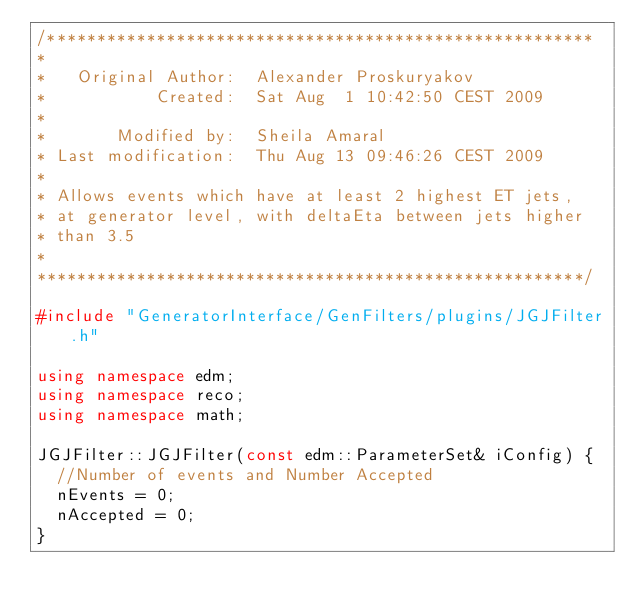Convert code to text. <code><loc_0><loc_0><loc_500><loc_500><_C++_>/*******************************************************
*
*   Original Author:  Alexander Proskuryakov
*           Created:  Sat Aug  1 10:42:50 CEST 2009
*
*       Modified by:  Sheila Amaral
* Last modification:  Thu Aug 13 09:46:26 CEST 2009
* 
* Allows events which have at least 2 highest ET jets,
* at generator level, with deltaEta between jets higher
* than 3.5
*
*******************************************************/

#include "GeneratorInterface/GenFilters/plugins/JGJFilter.h"

using namespace edm;
using namespace reco;
using namespace math;

JGJFilter::JGJFilter(const edm::ParameterSet& iConfig) {
  //Number of events and Number Accepted
  nEvents = 0;
  nAccepted = 0;
}
</code> 